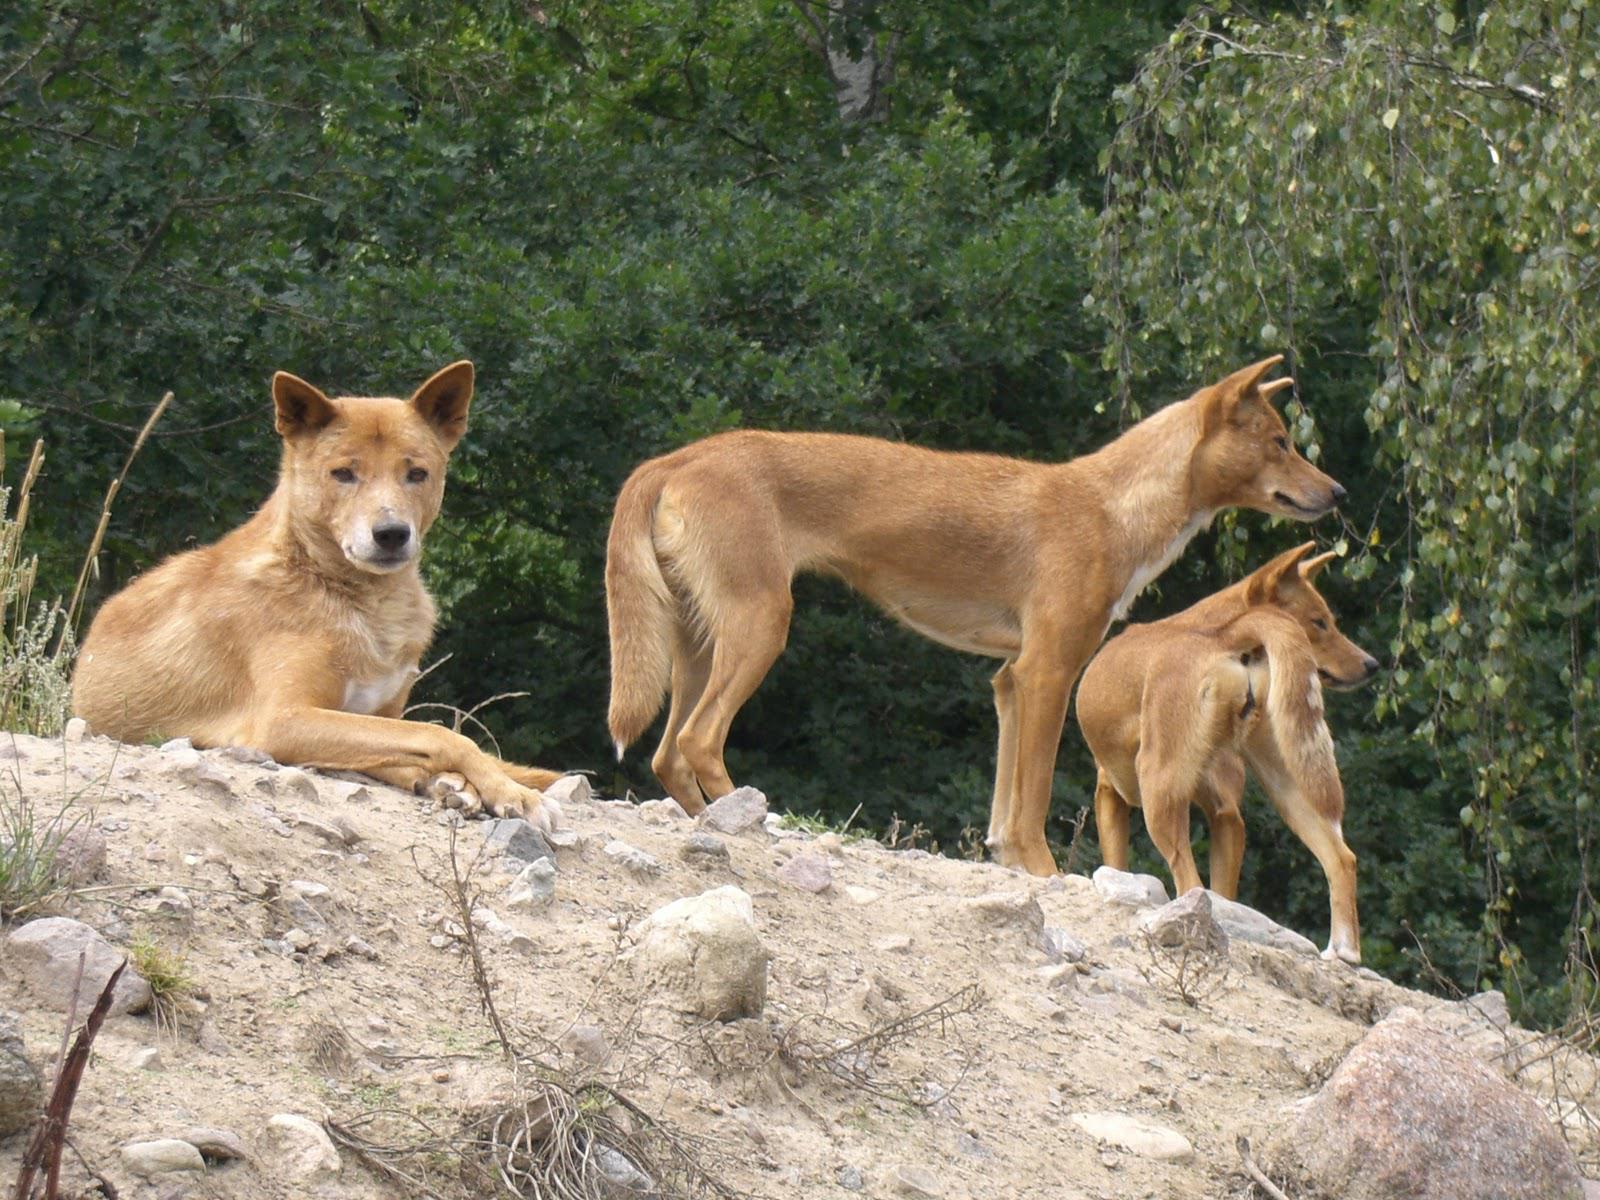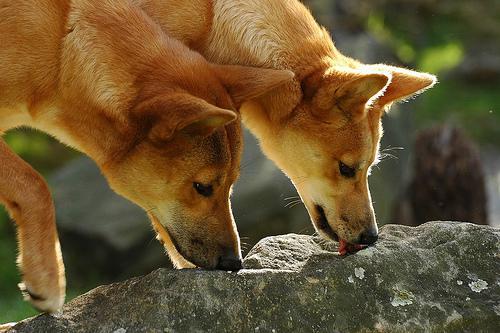The first image is the image on the left, the second image is the image on the right. For the images shown, is this caption "The combined images contain five dingos, and at least one dingo is reclining." true? Answer yes or no. Yes. 